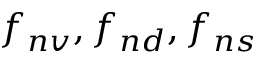Convert formula to latex. <formula><loc_0><loc_0><loc_500><loc_500>f _ { n v } , f _ { n d } , f _ { n s }</formula> 